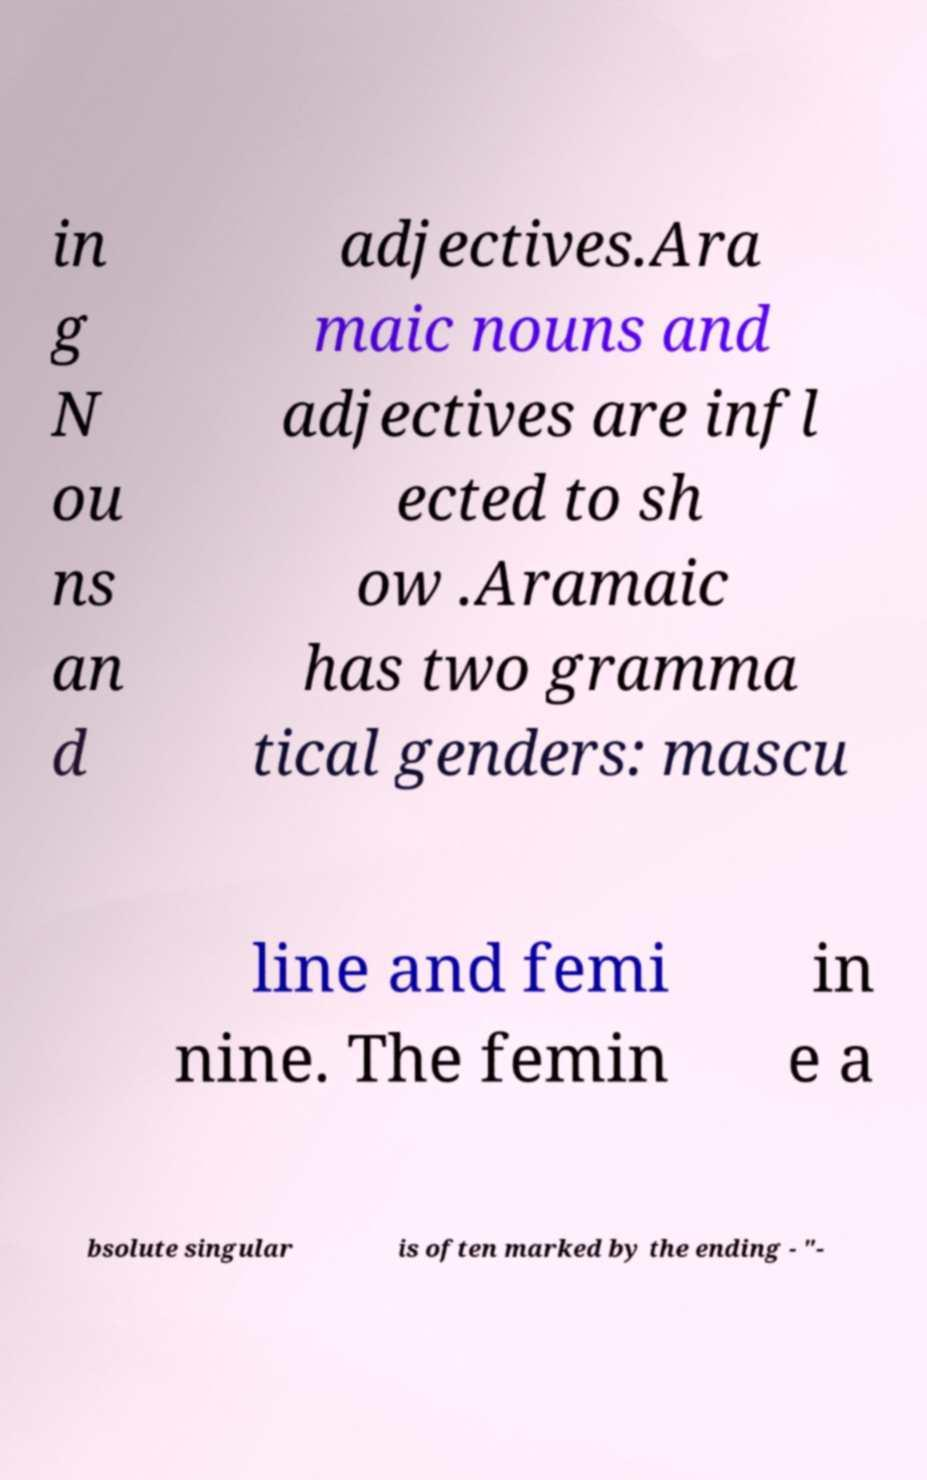Could you assist in decoding the text presented in this image and type it out clearly? in g N ou ns an d adjectives.Ara maic nouns and adjectives are infl ected to sh ow .Aramaic has two gramma tical genders: mascu line and femi nine. The femin in e a bsolute singular is often marked by the ending - "- 